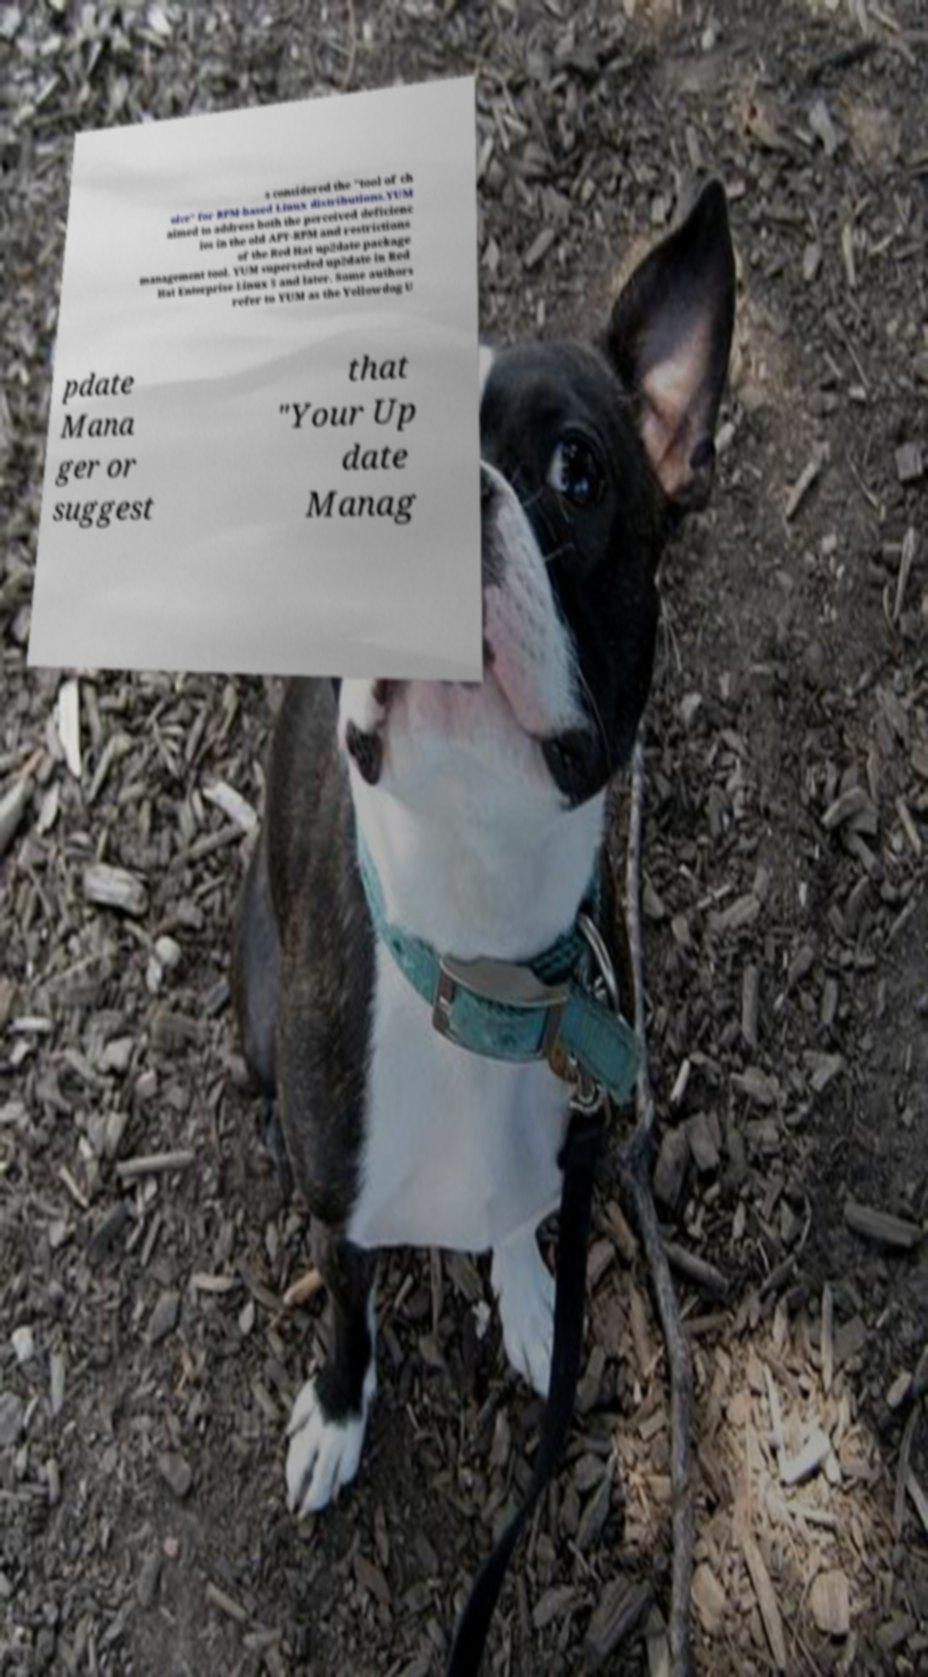Please identify and transcribe the text found in this image. s considered the "tool of ch oice" for RPM-based Linux distributions.YUM aimed to address both the perceived deficienc ies in the old APT-RPM and restrictions of the Red Hat up2date package management tool. YUM superseded up2date in Red Hat Enterprise Linux 5 and later. Some authors refer to YUM as the Yellowdog U pdate Mana ger or suggest that "Your Up date Manag 